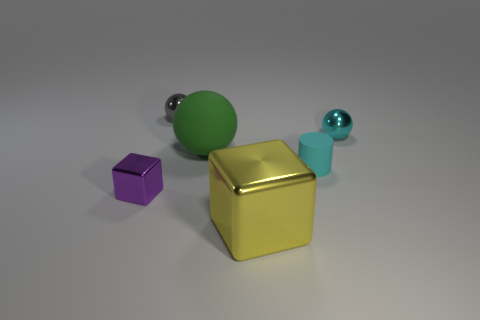Do the sphere that is to the right of the green object and the big shiny cube have the same size?
Provide a short and direct response. No. How many yellow metallic objects are the same shape as the tiny purple thing?
Provide a succinct answer. 1. What is the size of the object that is the same material as the big green ball?
Your response must be concise. Small. Are there the same number of metal objects that are left of the yellow object and blue balls?
Make the answer very short. No. Is the color of the big cube the same as the large matte ball?
Your answer should be very brief. No. There is a matte thing that is behind the cylinder; does it have the same shape as the cyan object left of the tiny cyan metallic object?
Your response must be concise. No. What material is the large yellow thing that is the same shape as the small purple metallic object?
Offer a very short reply. Metal. What is the color of the metallic object that is both to the right of the big green object and in front of the matte cylinder?
Offer a terse response. Yellow. Is there a small block behind the object that is left of the small ball that is to the left of the big green rubber ball?
Provide a succinct answer. No. What number of things are big balls or small gray metal objects?
Make the answer very short. 2. 